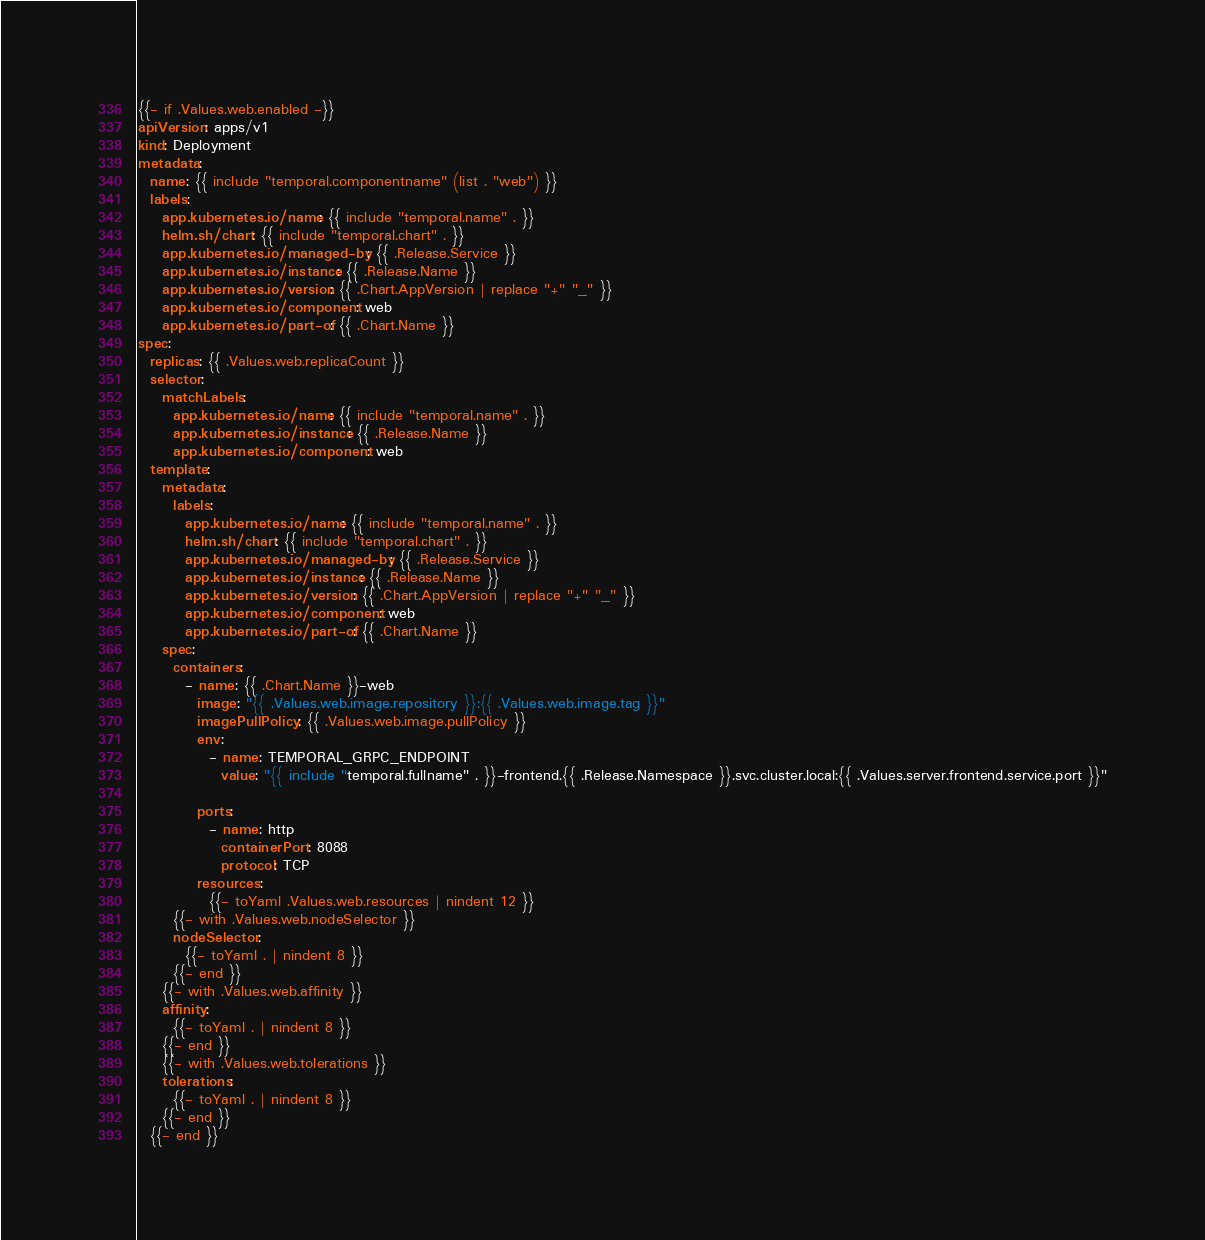Convert code to text. <code><loc_0><loc_0><loc_500><loc_500><_YAML_>{{- if .Values.web.enabled -}}
apiVersion: apps/v1
kind: Deployment
metadata:
  name: {{ include "temporal.componentname" (list . "web") }}
  labels:
    app.kubernetes.io/name: {{ include "temporal.name" . }}
    helm.sh/chart: {{ include "temporal.chart" . }}
    app.kubernetes.io/managed-by: {{ .Release.Service }}
    app.kubernetes.io/instance: {{ .Release.Name }}
    app.kubernetes.io/version: {{ .Chart.AppVersion | replace "+" "_" }}
    app.kubernetes.io/component: web
    app.kubernetes.io/part-of: {{ .Chart.Name }}
spec:
  replicas: {{ .Values.web.replicaCount }}
  selector:
    matchLabels:
      app.kubernetes.io/name: {{ include "temporal.name" . }}
      app.kubernetes.io/instance: {{ .Release.Name }}
      app.kubernetes.io/component: web
  template:
    metadata:
      labels:
        app.kubernetes.io/name: {{ include "temporal.name" . }}
        helm.sh/chart: {{ include "temporal.chart" . }}
        app.kubernetes.io/managed-by: {{ .Release.Service }}
        app.kubernetes.io/instance: {{ .Release.Name }}
        app.kubernetes.io/version: {{ .Chart.AppVersion | replace "+" "_" }}
        app.kubernetes.io/component: web
        app.kubernetes.io/part-of: {{ .Chart.Name }}
    spec:
      containers:
        - name: {{ .Chart.Name }}-web
          image: "{{ .Values.web.image.repository }}:{{ .Values.web.image.tag }}"
          imagePullPolicy: {{ .Values.web.image.pullPolicy }}
          env:
            - name: TEMPORAL_GRPC_ENDPOINT
              value: "{{ include "temporal.fullname" . }}-frontend.{{ .Release.Namespace }}.svc.cluster.local:{{ .Values.server.frontend.service.port }}"

          ports:
            - name: http
              containerPort: 8088
              protocol: TCP
          resources:
            {{- toYaml .Values.web.resources | nindent 12 }}
      {{- with .Values.web.nodeSelector }}
      nodeSelector:
        {{- toYaml . | nindent 8 }}
      {{- end }}
    {{- with .Values.web.affinity }}
    affinity:
      {{- toYaml . | nindent 8 }}
    {{- end }}
    {{- with .Values.web.tolerations }}
    tolerations:
      {{- toYaml . | nindent 8 }}
    {{- end }}
  {{- end }}</code> 